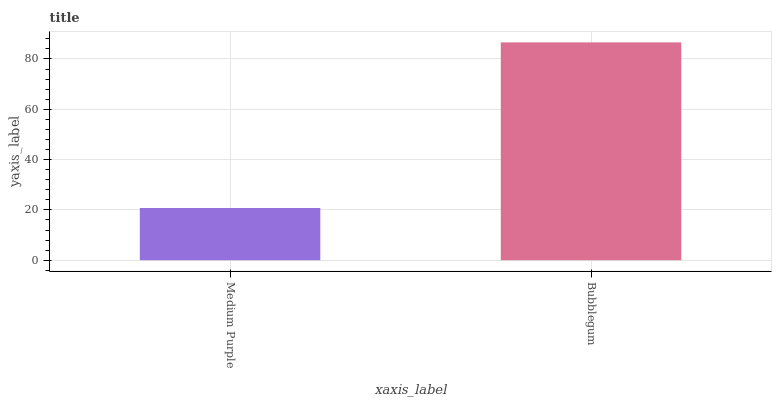Is Medium Purple the minimum?
Answer yes or no. Yes. Is Bubblegum the maximum?
Answer yes or no. Yes. Is Bubblegum the minimum?
Answer yes or no. No. Is Bubblegum greater than Medium Purple?
Answer yes or no. Yes. Is Medium Purple less than Bubblegum?
Answer yes or no. Yes. Is Medium Purple greater than Bubblegum?
Answer yes or no. No. Is Bubblegum less than Medium Purple?
Answer yes or no. No. Is Bubblegum the high median?
Answer yes or no. Yes. Is Medium Purple the low median?
Answer yes or no. Yes. Is Medium Purple the high median?
Answer yes or no. No. Is Bubblegum the low median?
Answer yes or no. No. 